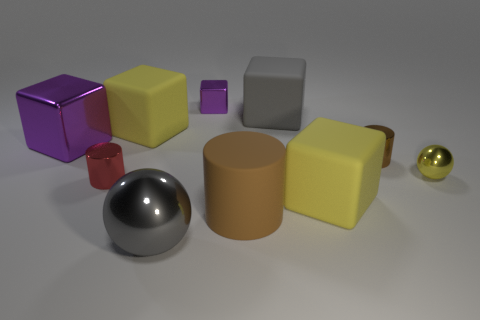What is the material of the yellow sphere that is the same size as the brown shiny cylinder?
Ensure brevity in your answer.  Metal. There is a gray object that is made of the same material as the big brown cylinder; what size is it?
Provide a succinct answer. Large. What number of other objects are the same shape as the tiny brown thing?
Make the answer very short. 2. What number of blocks are in front of the red metallic cylinder?
Your answer should be very brief. 1. There is a cylinder that is behind the brown rubber object and on the left side of the tiny brown cylinder; how big is it?
Offer a very short reply. Small. Are there any small gray cubes?
Keep it short and to the point. No. What number of other objects are the same size as the gray metallic sphere?
Your answer should be very brief. 5. There is a large shiny thing that is left of the large ball; is its color the same as the tiny shiny cube left of the small yellow metal thing?
Your response must be concise. Yes. There is a brown rubber object that is the same shape as the red object; what is its size?
Your response must be concise. Large. Is the large gray object behind the big brown matte object made of the same material as the large yellow object that is in front of the large purple metal block?
Offer a terse response. Yes. 